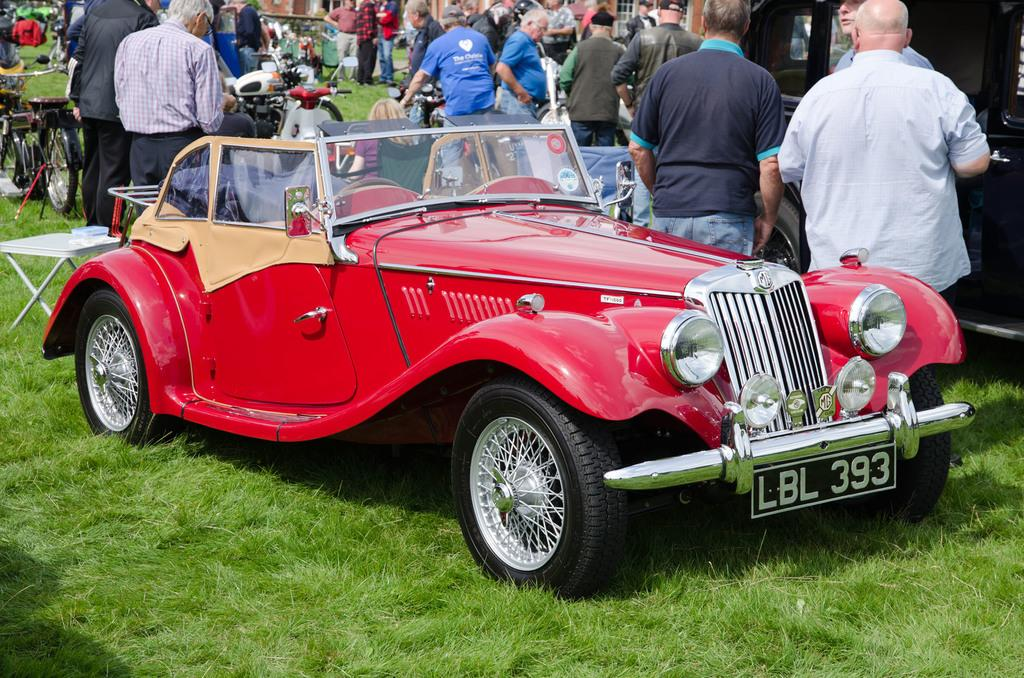How many vehicles are present in the image? There are two cars and some motorcycles in the image, making a total of at least three vehicles. What type of transportation is not present in the image? There is no bicycle visible in the image. What structure can be seen in the background of the image? There is a house in the image. What type of surface is visible in the image? There is grass visible in the image. What object might be used for eating or working on in the image? There is a table in the image. Can you see a snake slithering through the grass in the image? There is no snake present in the image; only people, cars, motorcycles, a bicycle, a house, a table, and grass are visible. What type of bun is being served on the table in the image? There is no bun present in the image; only a table is visible. 